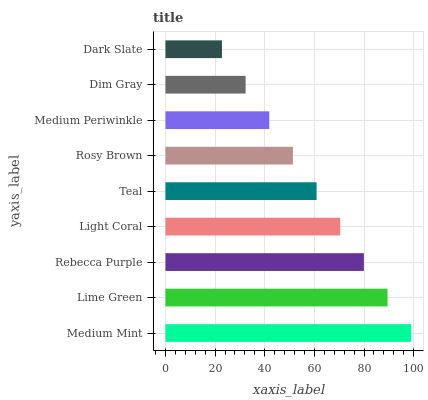Is Dark Slate the minimum?
Answer yes or no. Yes. Is Medium Mint the maximum?
Answer yes or no. Yes. Is Lime Green the minimum?
Answer yes or no. No. Is Lime Green the maximum?
Answer yes or no. No. Is Medium Mint greater than Lime Green?
Answer yes or no. Yes. Is Lime Green less than Medium Mint?
Answer yes or no. Yes. Is Lime Green greater than Medium Mint?
Answer yes or no. No. Is Medium Mint less than Lime Green?
Answer yes or no. No. Is Teal the high median?
Answer yes or no. Yes. Is Teal the low median?
Answer yes or no. Yes. Is Medium Periwinkle the high median?
Answer yes or no. No. Is Dark Slate the low median?
Answer yes or no. No. 